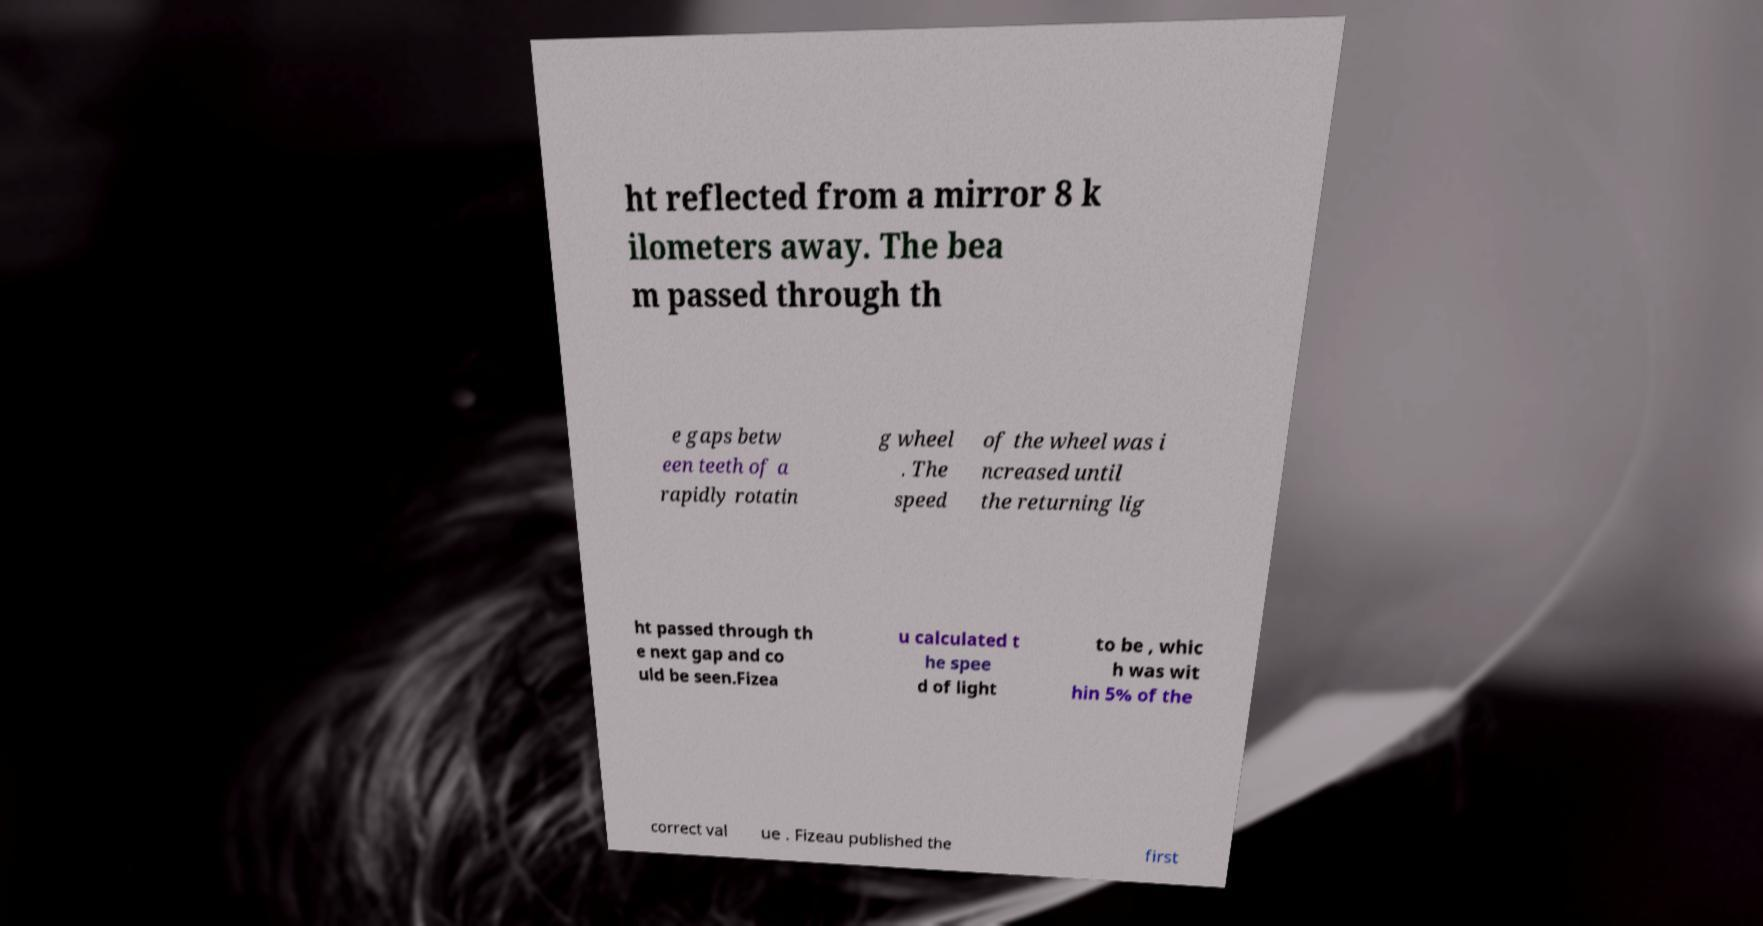Could you assist in decoding the text presented in this image and type it out clearly? ht reflected from a mirror 8 k ilometers away. The bea m passed through th e gaps betw een teeth of a rapidly rotatin g wheel . The speed of the wheel was i ncreased until the returning lig ht passed through th e next gap and co uld be seen.Fizea u calculated t he spee d of light to be , whic h was wit hin 5% of the correct val ue . Fizeau published the first 